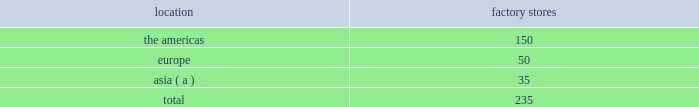We operated the following factory stores as of march 29 , 2014: .
( a ) includes australia , china , hong kong , japan , malaysia , south korea , and taiwan .
Our factory stores in the americas offer selections of our menswear , womenswear , childrenswear , accessories , home furnishings , and fragrances .
Ranging in size from approximately 2700 to 20000 square feet , with an average of approximately 10400 square feet , these stores are principally located in major outlet centers in 40 states in the u.s. , canada , and puerto rico .
Our factory stores in europe offer selections of our menswear , womenswear , childrenswear , accessories , home furnishings , and fragrances .
Ranging in size from approximately 1400 to 19700 square feet , with an average of approximately 7000 square feet , these stores are located in 12 countries , principally in major outlet centers .
Our factory stores in asia offer selections of our menswear , womenswear , childrenswear , accessories , and fragrances .
Ranging in size from approximately 1100 to 11800 square feet , with an average of approximately 6200 square feet , these stores are primarily located throughout china and japan , in hong kong , and in or near other major cities in asia and australia .
Our factory stores are principally located in major outlet centers .
Factory stores obtain products from our suppliers , our product licensing partners , and our other retail stores and e-commerce operations , and also serve as a secondary distribution channel for our excess and out-of-season products .
Concession-based shop-within-shops the terms of trade for shop-within-shops are largely conducted on a concession basis , whereby inventory continues to be owned by us ( not the department store ) until ultimate sale to the end consumer .
The salespeople involved in the sales transactions are generally our employees and not those of the department store .
As of march 29 , 2014 , we had 503 concession-based shop-within-shops at 243 retail locations dedicated to our products , which were located in asia , australia , new zealand , and europe .
The size of our concession-based shop-within-shops ranges from approximately 140 to 7400 square feet .
We may share in the cost of building-out certain of these shop-within-shops with our department store partners .
E-commerce websites in addition to our stores , our retail segment sells products online through our e-commerce channel , which includes : 2022 our north american e-commerce sites located at www.ralphlauren.com and www.clubmonaco.com , as well as our club monaco site in canada located at www.clubmonaco.ca ; 2022 our ralph lauren e-commerce sites in europe , including www.ralphlauren.co.uk ( servicing the united kingdom ) , www.ralphlauren.fr ( servicing belgium , france , italy , luxembourg , the netherlands , portugal , and spain ) , and www.ralphlauren.de ( servicing germany and austria ) ; and 2022 our ralph lauren e-commerce sites in asia , including www.ralphlauren.co.jp servicing japan and www.ralphlauren.co.kr servicing south korea .
Our ralph lauren e-commerce sites in the u.s. , europe , and asia offer our customers access to a broad array of ralph lauren , rrl , polo , and denim & supply apparel , accessories , fragrance , and home products , and reinforce the luxury image of our brands .
While investing in e-commerce operations remains a primary focus , it is an extension of our investment in the integrated omni-channel strategy used to operate our overall retail business , in which our e-commerce operations are interdependent with our physical stores .
Our club monaco e-commerce sites in the u.s .
And canada offer our domestic and canadian customers access to our club monaco global assortment of womenswear , menswear , and accessories product lines , as well as select online exclusives. .
What percentage of factory stores as of march 29 , 2014 are in the americas? 
Computations: (150 / 235)
Answer: 0.6383. 